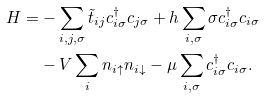Convert formula to latex. <formula><loc_0><loc_0><loc_500><loc_500>H = & - \sum _ { i , j , \sigma } \tilde { t } _ { i j } c _ { i \sigma } ^ { \dagger } c _ { j \sigma } + h \sum _ { i , \sigma } \sigma c _ { i \sigma } ^ { \dagger } c _ { i \sigma } \\ & - V \sum _ { i } n _ { i \uparrow } n _ { i \downarrow } - \mu \sum _ { i , \sigma } c _ { i \sigma } ^ { \dagger } c _ { i \sigma } .</formula> 